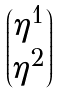<formula> <loc_0><loc_0><loc_500><loc_500>\begin{pmatrix} \eta ^ { 1 } \\ \eta ^ { 2 } \end{pmatrix}</formula> 